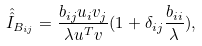Convert formula to latex. <formula><loc_0><loc_0><loc_500><loc_500>\hat { \hat { I } } _ { B _ { i j } } = \frac { b _ { i j } u _ { i } v _ { j } } { \lambda u ^ { T } v } ( 1 + \delta _ { i j } \frac { b _ { i i } } { \lambda } ) ,</formula> 